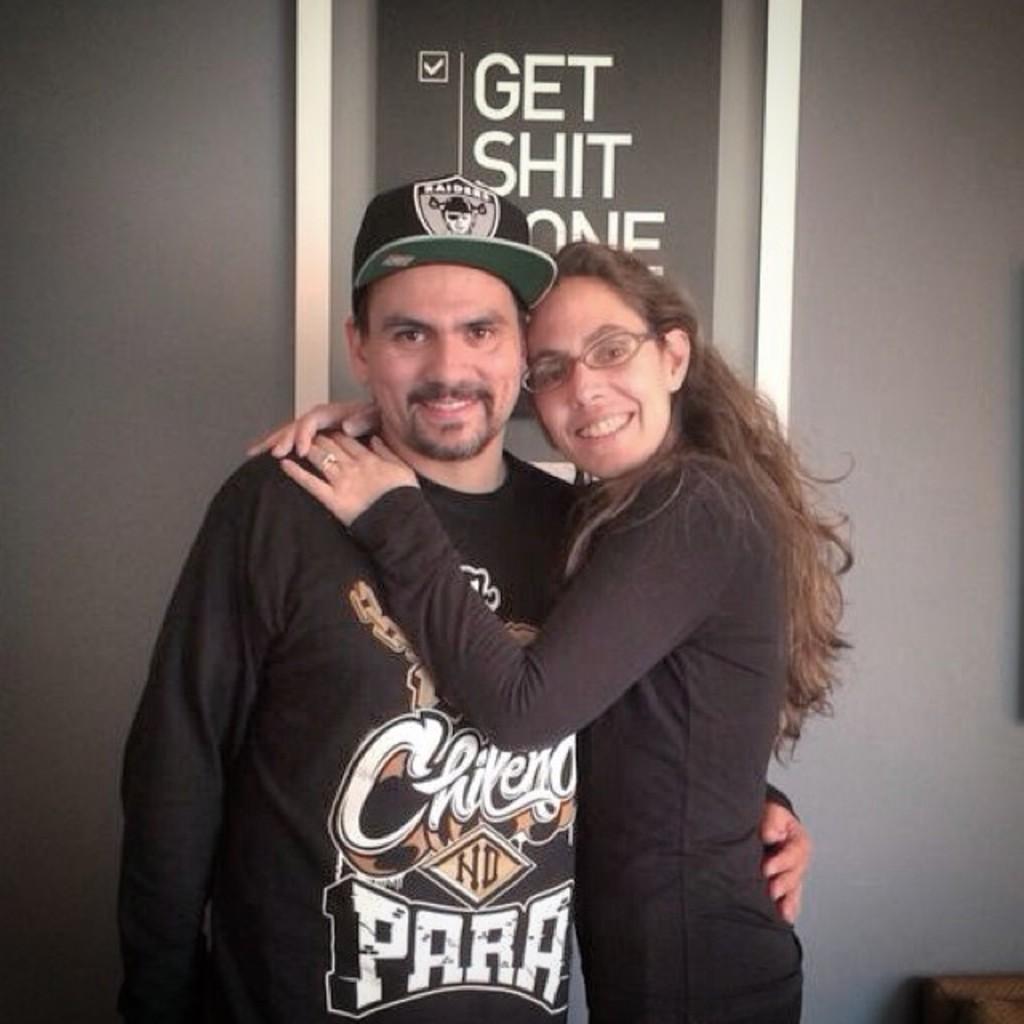What team is on his hat?
Offer a very short reply. Raiders. What is written on the sign in the background?
Give a very brief answer. Get shit done. 